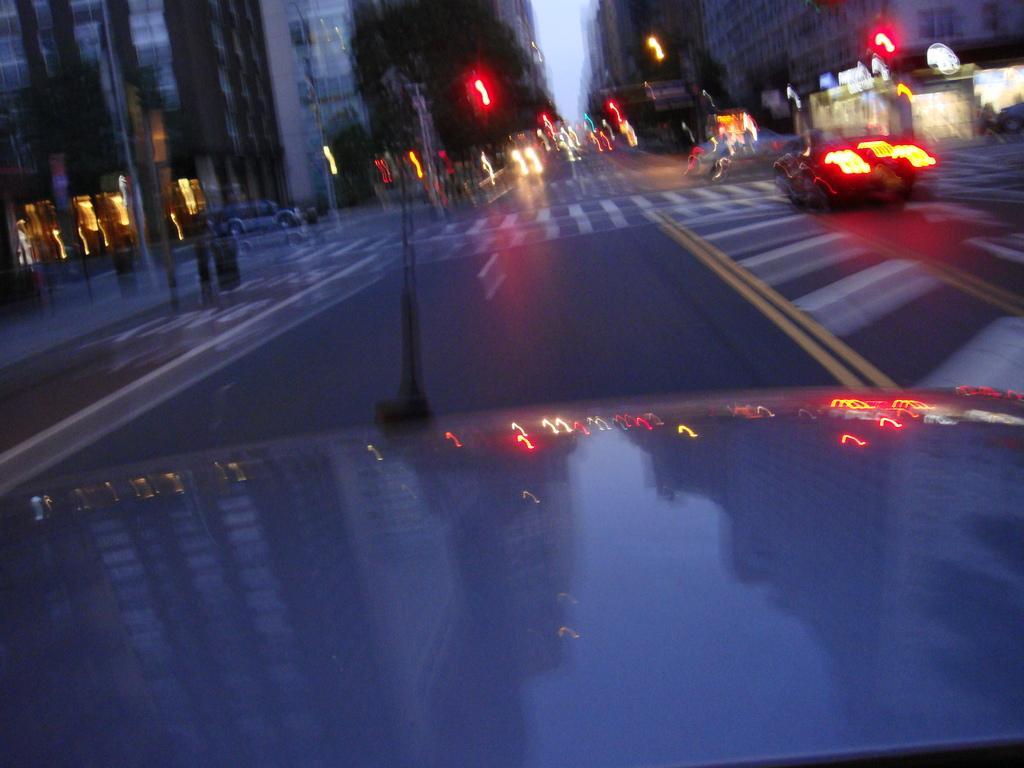Please provide a concise description of this image. In the picture I can see vehicles on the road. In the background I can see street lights, buildings and the sky. This image is blurred. 